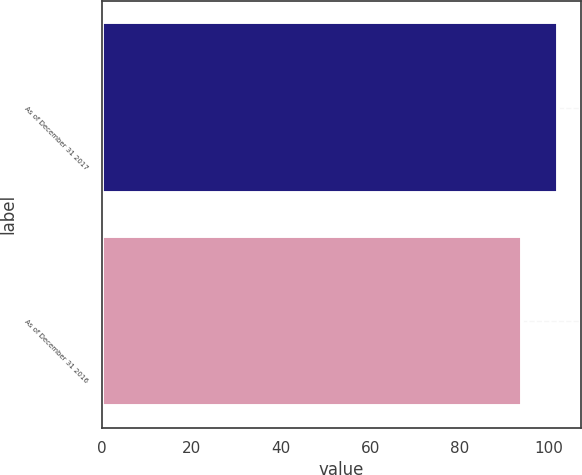<chart> <loc_0><loc_0><loc_500><loc_500><bar_chart><fcel>As of December 31 2017<fcel>As of December 31 2016<nl><fcel>102<fcel>94<nl></chart> 